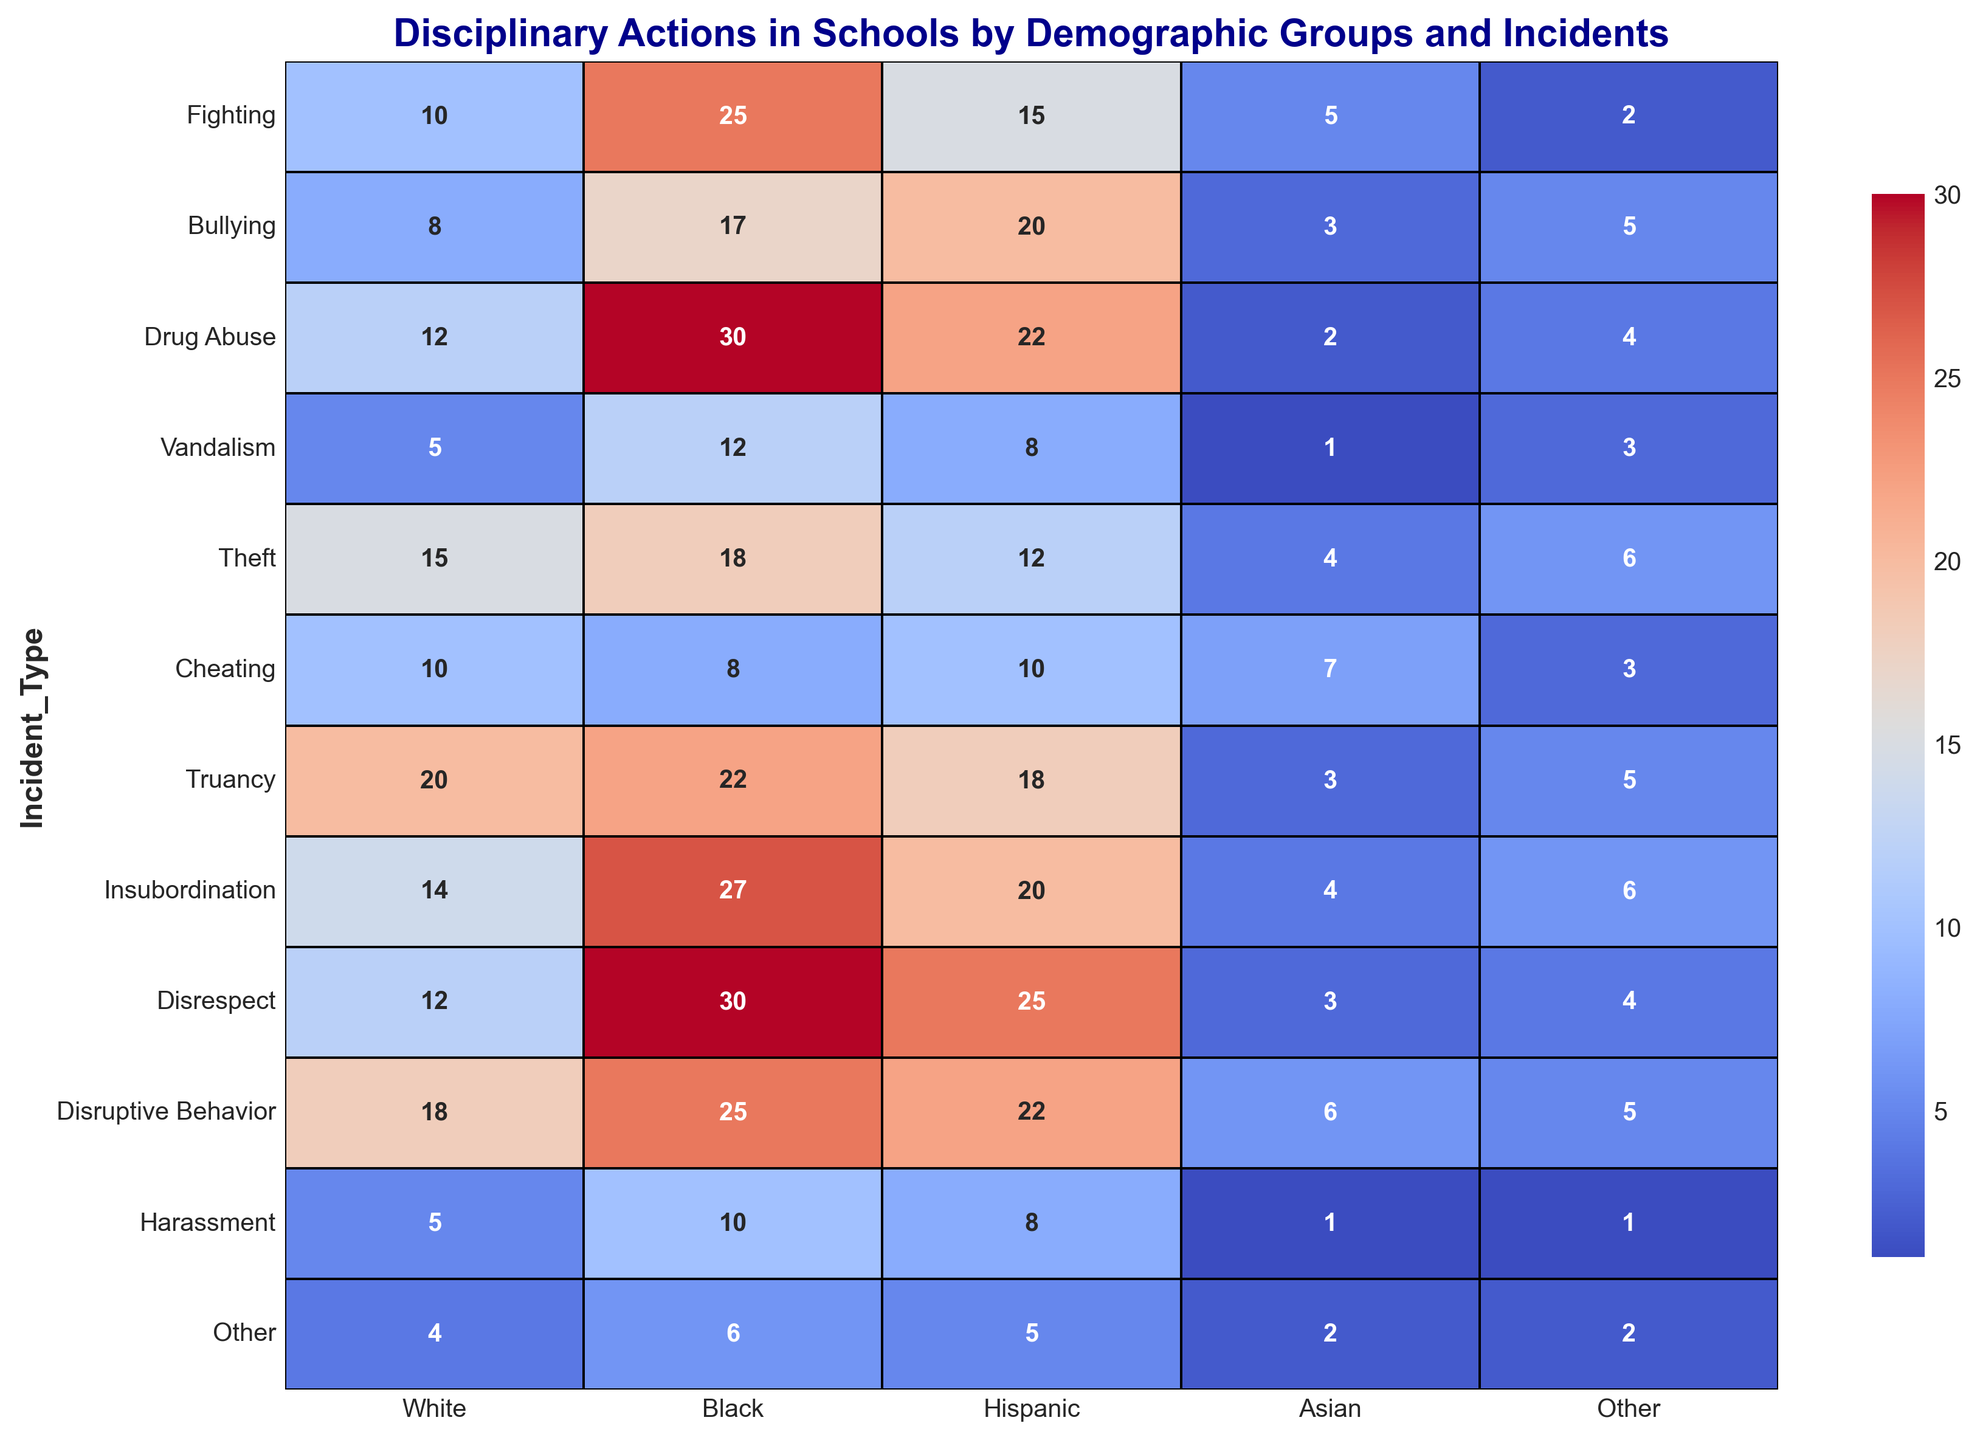How many more incidents of Drug Abuse were reported for Black students compared to Hispanic students? To find the answer, look at the number of Drug Abuse incidents for Black and Hispanic students. Black students have 30 incidents, while Hispanic students have 22. The difference is 30 - 22 = 8.
Answer: 8 Which demographic group has the lowest number of reported incidents for Harassment? Look at the Harassment row and identify the group with the smallest number. Asian and Other groups both report 1 incident.
Answer: Asian and Other Are the reported incidents of Fighting higher for White students or Black students? Compare the numbers in the Fighting row for White and Black students. White students have 10 incidents, while Black students have 25. 25 is greater than 10.
Answer: Black students Which incident type has the highest number of reported incidents for Hispanic students? Scan the Hispanic column to find the largest number. Disrespect has the highest at 25 incidents.
Answer: Disrespect What is the total number of incidents reported across all demographic groups for Bullying? Sum up the numbers in the Bullying row: 8 (White) + 17 (Black) + 20 (Hispanic) + 3 (Asian) + 5 (Other) = 53.
Answer: 53 What is the average number of incidents reported for Truancy across all demographic groups? Calculate the average by adding all incidents in the Truancy row, then dividing by the number of groups: (20 + 22 + 18 + 3 + 5) / 5 = 68 / 5 = 13.6.
Answer: 13.6 How does the number of reported incidents for Cheating compare between Asian and Other students? Compare the numbers in the Cheating row for Asian and Other students. Asian students have 7 incidents, and Other students have 3 incidents. 7 is higher than 3.
Answer: Cheating incidents are higher for Asian students Which demographic group has the highest total number of reported incidents across all incident types? Sum the numbers in each demographic column: (White:112, Black:242, Hispanic:185, Asian:37, Other:46). Black students have the highest total.
Answer: Black students Among all the incident types, which one shows the smallest disparity between the highest and lowest reported incidents across demographic groups? Calculate the difference between the highest and lowest numbers in each row: Other incidents have the smallest disparity (6 - 2 = 4).
Answer: Other incidents 